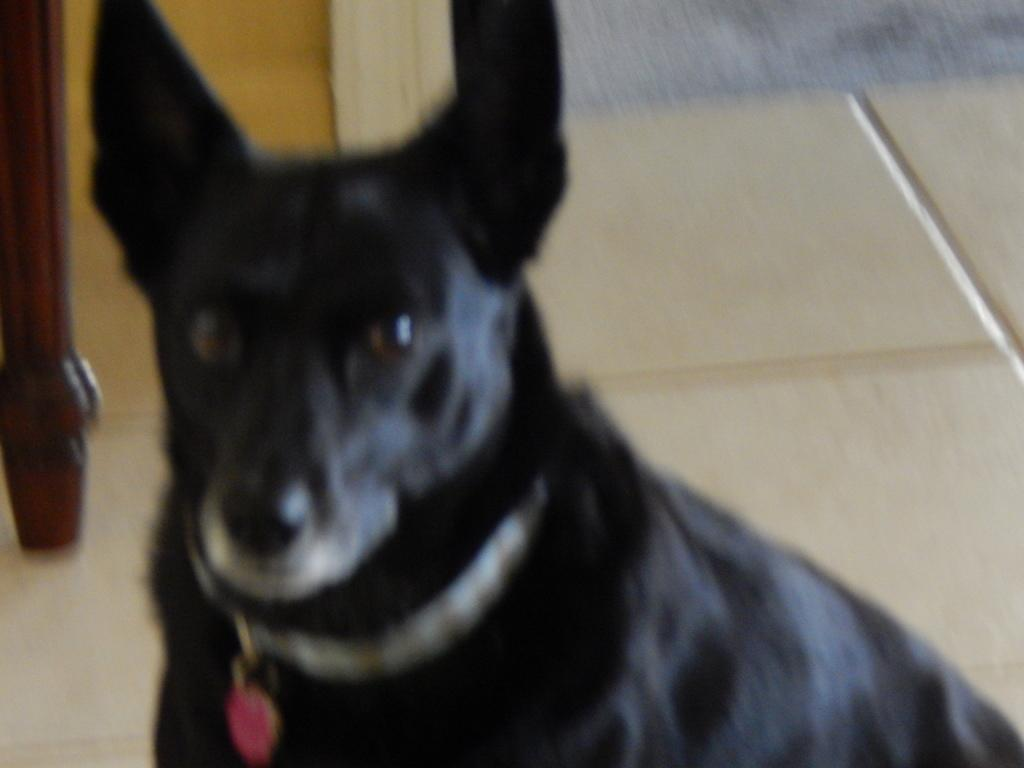What type of animal is in the picture? There is a black color dog in the picture. What is the dog doing in the picture? The dog is looking into the camera. What can be seen in the background of the picture? There is flooring tile and a yellow color wall visible in the background. What type of knowledge can be gained from the dog's expression in the image? There is no knowledge to be gained from the dog's expression in the image, as it is a photograph of a dog and not a source of information or wisdom. 